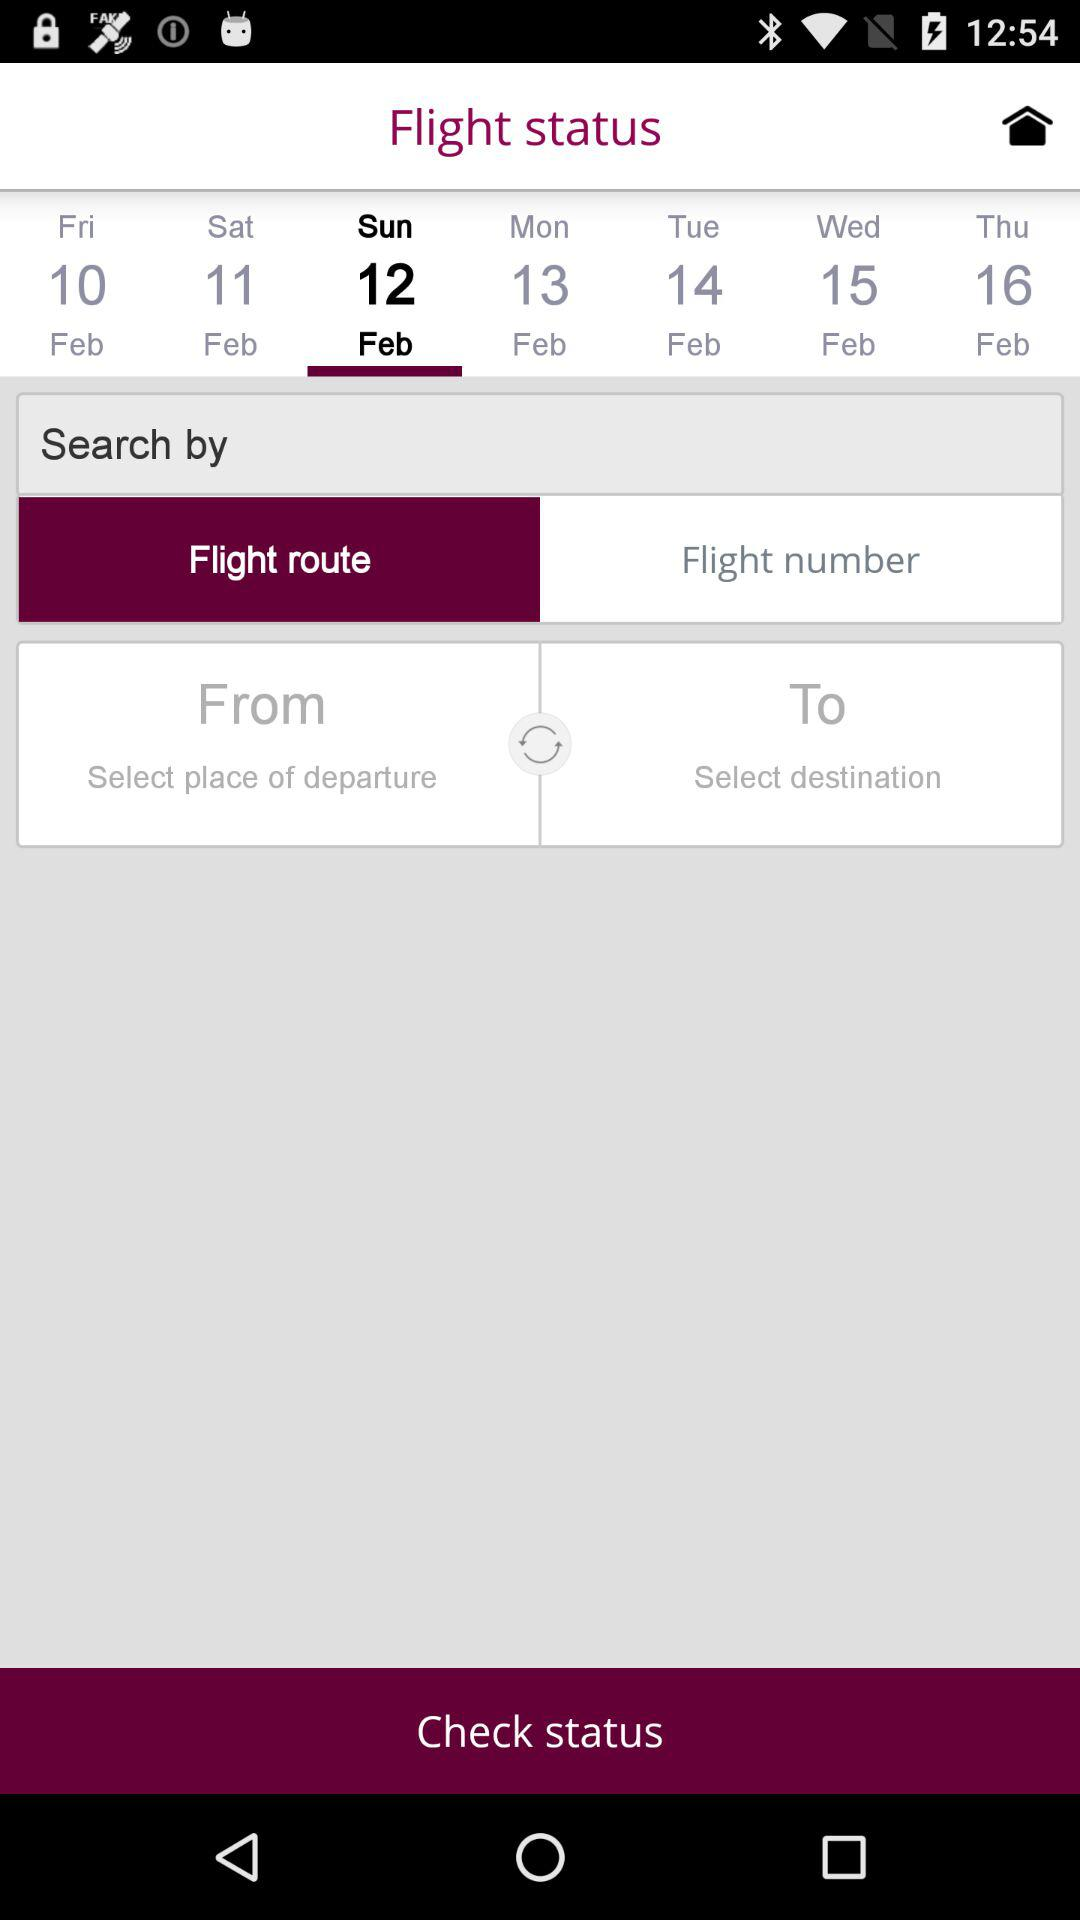Which option is selected in "Search by"? The selected option is "Flight route". 